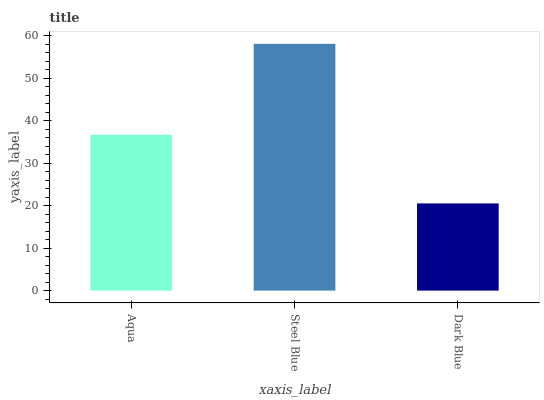Is Dark Blue the minimum?
Answer yes or no. Yes. Is Steel Blue the maximum?
Answer yes or no. Yes. Is Steel Blue the minimum?
Answer yes or no. No. Is Dark Blue the maximum?
Answer yes or no. No. Is Steel Blue greater than Dark Blue?
Answer yes or no. Yes. Is Dark Blue less than Steel Blue?
Answer yes or no. Yes. Is Dark Blue greater than Steel Blue?
Answer yes or no. No. Is Steel Blue less than Dark Blue?
Answer yes or no. No. Is Aqua the high median?
Answer yes or no. Yes. Is Aqua the low median?
Answer yes or no. Yes. Is Dark Blue the high median?
Answer yes or no. No. Is Steel Blue the low median?
Answer yes or no. No. 